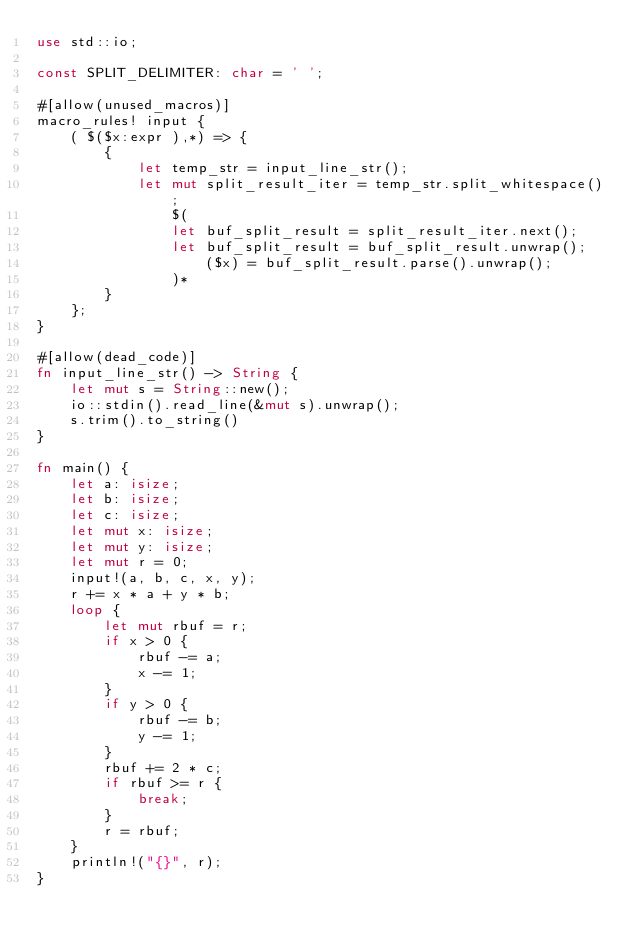<code> <loc_0><loc_0><loc_500><loc_500><_Rust_>use std::io;

const SPLIT_DELIMITER: char = ' ';

#[allow(unused_macros)]
macro_rules! input {
    ( $($x:expr ),*) => {
        {
            let temp_str = input_line_str();
            let mut split_result_iter = temp_str.split_whitespace();
                $(
                let buf_split_result = split_result_iter.next();
                let buf_split_result = buf_split_result.unwrap();
                    ($x) = buf_split_result.parse().unwrap();
                )*
        }
    };
}

#[allow(dead_code)]
fn input_line_str() -> String {
    let mut s = String::new();
    io::stdin().read_line(&mut s).unwrap();
    s.trim().to_string()
}

fn main() {
    let a: isize;
    let b: isize;
    let c: isize;
    let mut x: isize;
    let mut y: isize;
    let mut r = 0;
    input!(a, b, c, x, y);
    r += x * a + y * b;
    loop {
        let mut rbuf = r;
        if x > 0 {
            rbuf -= a;
            x -= 1;
        }
        if y > 0 {
            rbuf -= b;
            y -= 1;
        }
        rbuf += 2 * c;
        if rbuf >= r {
            break;
        }
        r = rbuf;
    }
    println!("{}", r);
}</code> 